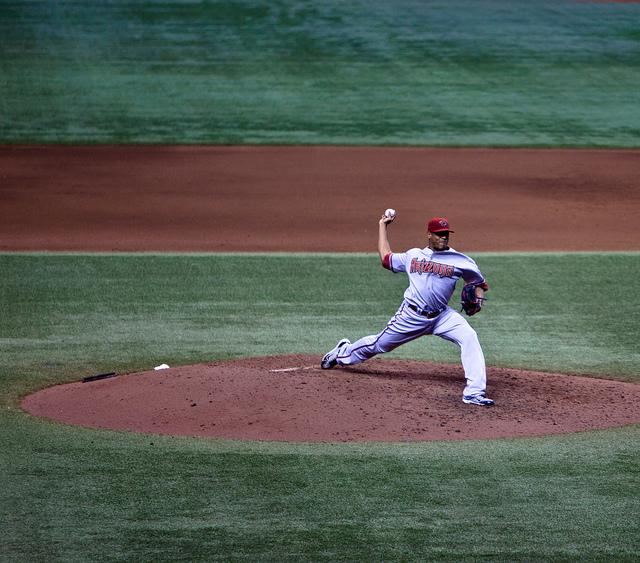What kind of throw is that called? Please explain your reasoning. pitch. The person is throwing the ball from the mound in the middle of a baseball diamond. 